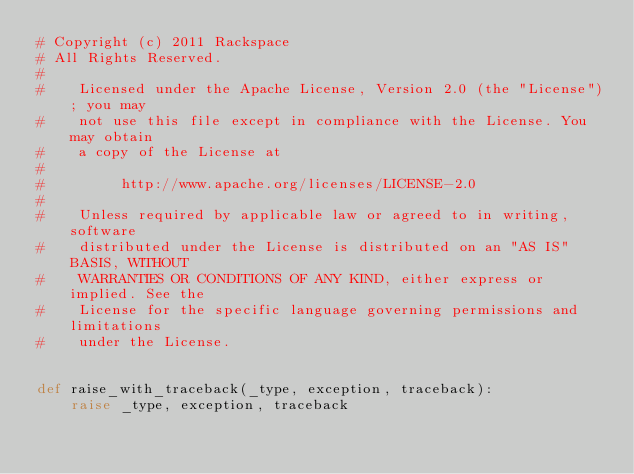<code> <loc_0><loc_0><loc_500><loc_500><_Python_># Copyright (c) 2011 Rackspace
# All Rights Reserved.
#
#    Licensed under the Apache License, Version 2.0 (the "License"); you may
#    not use this file except in compliance with the License. You may obtain
#    a copy of the License at
#
#         http://www.apache.org/licenses/LICENSE-2.0
#
#    Unless required by applicable law or agreed to in writing, software
#    distributed under the License is distributed on an "AS IS" BASIS, WITHOUT
#    WARRANTIES OR CONDITIONS OF ANY KIND, either express or implied. See the
#    License for the specific language governing permissions and limitations
#    under the License.


def raise_with_traceback(_type, exception, traceback):
    raise _type, exception, traceback
</code> 